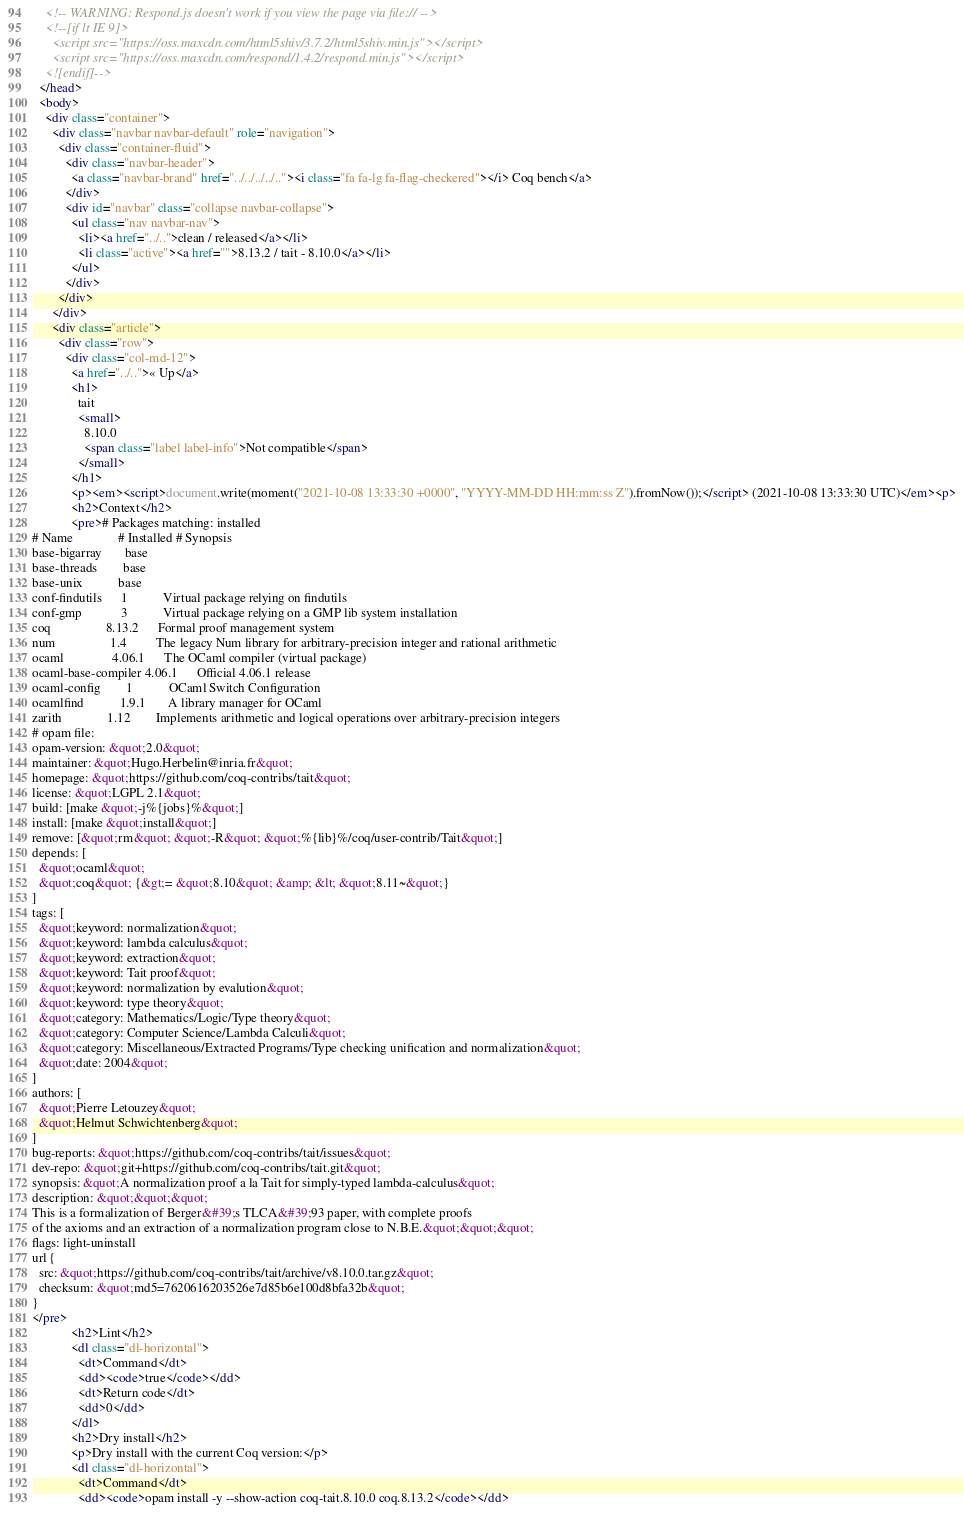Convert code to text. <code><loc_0><loc_0><loc_500><loc_500><_HTML_>    <!-- WARNING: Respond.js doesn't work if you view the page via file:// -->
    <!--[if lt IE 9]>
      <script src="https://oss.maxcdn.com/html5shiv/3.7.2/html5shiv.min.js"></script>
      <script src="https://oss.maxcdn.com/respond/1.4.2/respond.min.js"></script>
    <![endif]-->
  </head>
  <body>
    <div class="container">
      <div class="navbar navbar-default" role="navigation">
        <div class="container-fluid">
          <div class="navbar-header">
            <a class="navbar-brand" href="../../../../.."><i class="fa fa-lg fa-flag-checkered"></i> Coq bench</a>
          </div>
          <div id="navbar" class="collapse navbar-collapse">
            <ul class="nav navbar-nav">
              <li><a href="../..">clean / released</a></li>
              <li class="active"><a href="">8.13.2 / tait - 8.10.0</a></li>
            </ul>
          </div>
        </div>
      </div>
      <div class="article">
        <div class="row">
          <div class="col-md-12">
            <a href="../..">« Up</a>
            <h1>
              tait
              <small>
                8.10.0
                <span class="label label-info">Not compatible</span>
              </small>
            </h1>
            <p><em><script>document.write(moment("2021-10-08 13:33:30 +0000", "YYYY-MM-DD HH:mm:ss Z").fromNow());</script> (2021-10-08 13:33:30 UTC)</em><p>
            <h2>Context</h2>
            <pre># Packages matching: installed
# Name              # Installed # Synopsis
base-bigarray       base
base-threads        base
base-unix           base
conf-findutils      1           Virtual package relying on findutils
conf-gmp            3           Virtual package relying on a GMP lib system installation
coq                 8.13.2      Formal proof management system
num                 1.4         The legacy Num library for arbitrary-precision integer and rational arithmetic
ocaml               4.06.1      The OCaml compiler (virtual package)
ocaml-base-compiler 4.06.1      Official 4.06.1 release
ocaml-config        1           OCaml Switch Configuration
ocamlfind           1.9.1       A library manager for OCaml
zarith              1.12        Implements arithmetic and logical operations over arbitrary-precision integers
# opam file:
opam-version: &quot;2.0&quot;
maintainer: &quot;Hugo.Herbelin@inria.fr&quot;
homepage: &quot;https://github.com/coq-contribs/tait&quot;
license: &quot;LGPL 2.1&quot;
build: [make &quot;-j%{jobs}%&quot;]
install: [make &quot;install&quot;]
remove: [&quot;rm&quot; &quot;-R&quot; &quot;%{lib}%/coq/user-contrib/Tait&quot;]
depends: [
  &quot;ocaml&quot;
  &quot;coq&quot; {&gt;= &quot;8.10&quot; &amp; &lt; &quot;8.11~&quot;}
]
tags: [
  &quot;keyword: normalization&quot;
  &quot;keyword: lambda calculus&quot;
  &quot;keyword: extraction&quot;
  &quot;keyword: Tait proof&quot;
  &quot;keyword: normalization by evalution&quot;
  &quot;keyword: type theory&quot;
  &quot;category: Mathematics/Logic/Type theory&quot;
  &quot;category: Computer Science/Lambda Calculi&quot;
  &quot;category: Miscellaneous/Extracted Programs/Type checking unification and normalization&quot;
  &quot;date: 2004&quot;
]
authors: [
  &quot;Pierre Letouzey&quot;
  &quot;Helmut Schwichtenberg&quot;
]
bug-reports: &quot;https://github.com/coq-contribs/tait/issues&quot;
dev-repo: &quot;git+https://github.com/coq-contribs/tait.git&quot;
synopsis: &quot;A normalization proof a la Tait for simply-typed lambda-calculus&quot;
description: &quot;&quot;&quot;
This is a formalization of Berger&#39;s TLCA&#39;93 paper, with complete proofs
of the axioms and an extraction of a normalization program close to N.B.E.&quot;&quot;&quot;
flags: light-uninstall
url {
  src: &quot;https://github.com/coq-contribs/tait/archive/v8.10.0.tar.gz&quot;
  checksum: &quot;md5=7620616203526e7d85b6e100d8bfa32b&quot;
}
</pre>
            <h2>Lint</h2>
            <dl class="dl-horizontal">
              <dt>Command</dt>
              <dd><code>true</code></dd>
              <dt>Return code</dt>
              <dd>0</dd>
            </dl>
            <h2>Dry install</h2>
            <p>Dry install with the current Coq version:</p>
            <dl class="dl-horizontal">
              <dt>Command</dt>
              <dd><code>opam install -y --show-action coq-tait.8.10.0 coq.8.13.2</code></dd></code> 